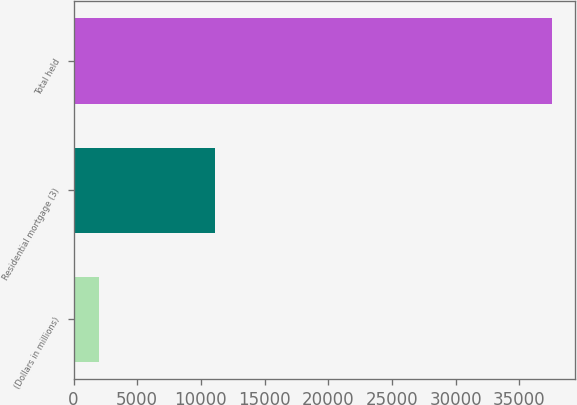<chart> <loc_0><loc_0><loc_500><loc_500><bar_chart><fcel>(Dollars in millions)<fcel>Residential mortgage (3)<fcel>Total held<nl><fcel>2009<fcel>11077<fcel>37541<nl></chart> 